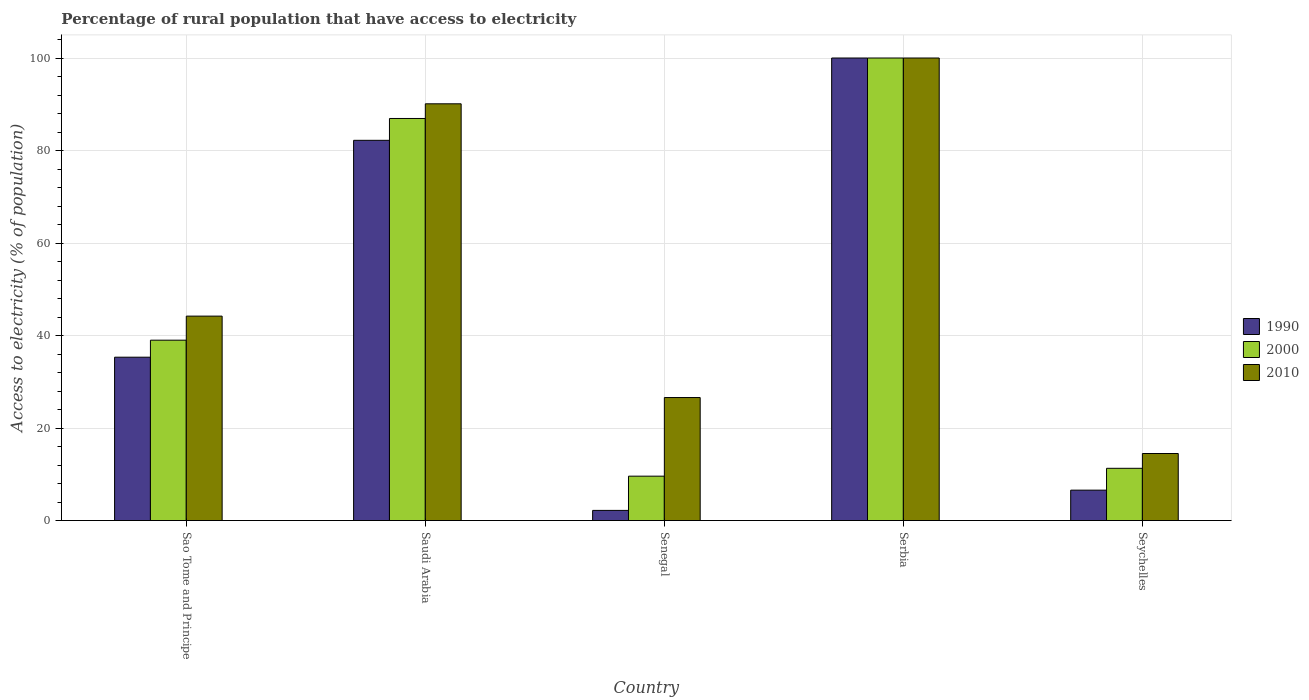How many different coloured bars are there?
Give a very brief answer. 3. How many groups of bars are there?
Make the answer very short. 5. How many bars are there on the 5th tick from the right?
Keep it short and to the point. 3. What is the label of the 1st group of bars from the left?
Your answer should be very brief. Sao Tome and Principe. What is the percentage of rural population that have access to electricity in 2000 in Seychelles?
Make the answer very short. 11.3. In which country was the percentage of rural population that have access to electricity in 2010 maximum?
Offer a very short reply. Serbia. In which country was the percentage of rural population that have access to electricity in 2010 minimum?
Give a very brief answer. Seychelles. What is the total percentage of rural population that have access to electricity in 2010 in the graph?
Provide a short and direct response. 275.4. What is the difference between the percentage of rural population that have access to electricity in 1990 in Sao Tome and Principe and that in Seychelles?
Keep it short and to the point. 28.74. What is the difference between the percentage of rural population that have access to electricity in 2000 in Sao Tome and Principe and the percentage of rural population that have access to electricity in 2010 in Senegal?
Provide a succinct answer. 12.4. What is the average percentage of rural population that have access to electricity in 2000 per country?
Offer a very short reply. 49.37. What is the difference between the percentage of rural population that have access to electricity of/in 2000 and percentage of rural population that have access to electricity of/in 2010 in Seychelles?
Make the answer very short. -3.2. In how many countries, is the percentage of rural population that have access to electricity in 2000 greater than 40 %?
Give a very brief answer. 2. What is the ratio of the percentage of rural population that have access to electricity in 2010 in Sao Tome and Principe to that in Saudi Arabia?
Offer a terse response. 0.49. Is the percentage of rural population that have access to electricity in 2000 in Sao Tome and Principe less than that in Saudi Arabia?
Offer a very short reply. Yes. What is the difference between the highest and the second highest percentage of rural population that have access to electricity in 2000?
Provide a succinct answer. 13.07. What is the difference between the highest and the lowest percentage of rural population that have access to electricity in 2010?
Ensure brevity in your answer.  85.5. Is it the case that in every country, the sum of the percentage of rural population that have access to electricity in 2000 and percentage of rural population that have access to electricity in 1990 is greater than the percentage of rural population that have access to electricity in 2010?
Provide a succinct answer. No. How many bars are there?
Keep it short and to the point. 15. Are all the bars in the graph horizontal?
Ensure brevity in your answer.  No. How many countries are there in the graph?
Your answer should be very brief. 5. What is the difference between two consecutive major ticks on the Y-axis?
Your response must be concise. 20. Where does the legend appear in the graph?
Offer a terse response. Center right. How many legend labels are there?
Provide a succinct answer. 3. What is the title of the graph?
Offer a very short reply. Percentage of rural population that have access to electricity. Does "2005" appear as one of the legend labels in the graph?
Provide a succinct answer. No. What is the label or title of the X-axis?
Offer a very short reply. Country. What is the label or title of the Y-axis?
Your answer should be compact. Access to electricity (% of population). What is the Access to electricity (% of population) in 1990 in Sao Tome and Principe?
Offer a very short reply. 35.32. What is the Access to electricity (% of population) of 2010 in Sao Tome and Principe?
Provide a short and direct response. 44.2. What is the Access to electricity (% of population) in 1990 in Saudi Arabia?
Provide a succinct answer. 82.2. What is the Access to electricity (% of population) in 2000 in Saudi Arabia?
Give a very brief answer. 86.93. What is the Access to electricity (% of population) in 2010 in Saudi Arabia?
Provide a succinct answer. 90.1. What is the Access to electricity (% of population) of 2000 in Senegal?
Offer a terse response. 9.6. What is the Access to electricity (% of population) of 2010 in Senegal?
Your answer should be compact. 26.6. What is the Access to electricity (% of population) of 1990 in Serbia?
Your answer should be very brief. 100. What is the Access to electricity (% of population) of 2010 in Serbia?
Provide a succinct answer. 100. What is the Access to electricity (% of population) in 1990 in Seychelles?
Ensure brevity in your answer.  6.58. What is the Access to electricity (% of population) of 2000 in Seychelles?
Provide a short and direct response. 11.3. Across all countries, what is the maximum Access to electricity (% of population) in 1990?
Your answer should be compact. 100. Across all countries, what is the minimum Access to electricity (% of population) in 1990?
Keep it short and to the point. 2.2. What is the total Access to electricity (% of population) in 1990 in the graph?
Keep it short and to the point. 226.3. What is the total Access to electricity (% of population) in 2000 in the graph?
Your response must be concise. 246.83. What is the total Access to electricity (% of population) of 2010 in the graph?
Your response must be concise. 275.4. What is the difference between the Access to electricity (% of population) in 1990 in Sao Tome and Principe and that in Saudi Arabia?
Give a very brief answer. -46.88. What is the difference between the Access to electricity (% of population) of 2000 in Sao Tome and Principe and that in Saudi Arabia?
Your response must be concise. -47.93. What is the difference between the Access to electricity (% of population) of 2010 in Sao Tome and Principe and that in Saudi Arabia?
Keep it short and to the point. -45.9. What is the difference between the Access to electricity (% of population) of 1990 in Sao Tome and Principe and that in Senegal?
Give a very brief answer. 33.12. What is the difference between the Access to electricity (% of population) of 2000 in Sao Tome and Principe and that in Senegal?
Provide a short and direct response. 29.4. What is the difference between the Access to electricity (% of population) of 1990 in Sao Tome and Principe and that in Serbia?
Ensure brevity in your answer.  -64.68. What is the difference between the Access to electricity (% of population) in 2000 in Sao Tome and Principe and that in Serbia?
Your answer should be very brief. -61. What is the difference between the Access to electricity (% of population) in 2010 in Sao Tome and Principe and that in Serbia?
Make the answer very short. -55.8. What is the difference between the Access to electricity (% of population) in 1990 in Sao Tome and Principe and that in Seychelles?
Give a very brief answer. 28.74. What is the difference between the Access to electricity (% of population) in 2000 in Sao Tome and Principe and that in Seychelles?
Give a very brief answer. 27.7. What is the difference between the Access to electricity (% of population) in 2010 in Sao Tome and Principe and that in Seychelles?
Your response must be concise. 29.7. What is the difference between the Access to electricity (% of population) of 1990 in Saudi Arabia and that in Senegal?
Give a very brief answer. 80. What is the difference between the Access to electricity (% of population) of 2000 in Saudi Arabia and that in Senegal?
Give a very brief answer. 77.33. What is the difference between the Access to electricity (% of population) of 2010 in Saudi Arabia and that in Senegal?
Keep it short and to the point. 63.5. What is the difference between the Access to electricity (% of population) in 1990 in Saudi Arabia and that in Serbia?
Provide a succinct answer. -17.8. What is the difference between the Access to electricity (% of population) of 2000 in Saudi Arabia and that in Serbia?
Give a very brief answer. -13.07. What is the difference between the Access to electricity (% of population) in 2010 in Saudi Arabia and that in Serbia?
Make the answer very short. -9.9. What is the difference between the Access to electricity (% of population) in 1990 in Saudi Arabia and that in Seychelles?
Give a very brief answer. 75.62. What is the difference between the Access to electricity (% of population) of 2000 in Saudi Arabia and that in Seychelles?
Make the answer very short. 75.62. What is the difference between the Access to electricity (% of population) in 2010 in Saudi Arabia and that in Seychelles?
Your answer should be very brief. 75.6. What is the difference between the Access to electricity (% of population) of 1990 in Senegal and that in Serbia?
Your answer should be very brief. -97.8. What is the difference between the Access to electricity (% of population) of 2000 in Senegal and that in Serbia?
Your answer should be very brief. -90.4. What is the difference between the Access to electricity (% of population) of 2010 in Senegal and that in Serbia?
Ensure brevity in your answer.  -73.4. What is the difference between the Access to electricity (% of population) in 1990 in Senegal and that in Seychelles?
Ensure brevity in your answer.  -4.38. What is the difference between the Access to electricity (% of population) of 2000 in Senegal and that in Seychelles?
Your response must be concise. -1.7. What is the difference between the Access to electricity (% of population) in 2010 in Senegal and that in Seychelles?
Offer a very short reply. 12.1. What is the difference between the Access to electricity (% of population) of 1990 in Serbia and that in Seychelles?
Make the answer very short. 93.42. What is the difference between the Access to electricity (% of population) of 2000 in Serbia and that in Seychelles?
Provide a short and direct response. 88.7. What is the difference between the Access to electricity (% of population) in 2010 in Serbia and that in Seychelles?
Provide a succinct answer. 85.5. What is the difference between the Access to electricity (% of population) of 1990 in Sao Tome and Principe and the Access to electricity (% of population) of 2000 in Saudi Arabia?
Offer a very short reply. -51.61. What is the difference between the Access to electricity (% of population) in 1990 in Sao Tome and Principe and the Access to electricity (% of population) in 2010 in Saudi Arabia?
Offer a terse response. -54.78. What is the difference between the Access to electricity (% of population) of 2000 in Sao Tome and Principe and the Access to electricity (% of population) of 2010 in Saudi Arabia?
Offer a terse response. -51.1. What is the difference between the Access to electricity (% of population) in 1990 in Sao Tome and Principe and the Access to electricity (% of population) in 2000 in Senegal?
Offer a terse response. 25.72. What is the difference between the Access to electricity (% of population) of 1990 in Sao Tome and Principe and the Access to electricity (% of population) of 2010 in Senegal?
Give a very brief answer. 8.72. What is the difference between the Access to electricity (% of population) of 1990 in Sao Tome and Principe and the Access to electricity (% of population) of 2000 in Serbia?
Ensure brevity in your answer.  -64.68. What is the difference between the Access to electricity (% of population) of 1990 in Sao Tome and Principe and the Access to electricity (% of population) of 2010 in Serbia?
Offer a terse response. -64.68. What is the difference between the Access to electricity (% of population) in 2000 in Sao Tome and Principe and the Access to electricity (% of population) in 2010 in Serbia?
Make the answer very short. -61. What is the difference between the Access to electricity (% of population) in 1990 in Sao Tome and Principe and the Access to electricity (% of population) in 2000 in Seychelles?
Your answer should be very brief. 24.02. What is the difference between the Access to electricity (% of population) of 1990 in Sao Tome and Principe and the Access to electricity (% of population) of 2010 in Seychelles?
Offer a terse response. 20.82. What is the difference between the Access to electricity (% of population) in 2000 in Sao Tome and Principe and the Access to electricity (% of population) in 2010 in Seychelles?
Give a very brief answer. 24.5. What is the difference between the Access to electricity (% of population) in 1990 in Saudi Arabia and the Access to electricity (% of population) in 2000 in Senegal?
Offer a very short reply. 72.6. What is the difference between the Access to electricity (% of population) in 1990 in Saudi Arabia and the Access to electricity (% of population) in 2010 in Senegal?
Provide a succinct answer. 55.6. What is the difference between the Access to electricity (% of population) in 2000 in Saudi Arabia and the Access to electricity (% of population) in 2010 in Senegal?
Provide a succinct answer. 60.33. What is the difference between the Access to electricity (% of population) of 1990 in Saudi Arabia and the Access to electricity (% of population) of 2000 in Serbia?
Make the answer very short. -17.8. What is the difference between the Access to electricity (% of population) in 1990 in Saudi Arabia and the Access to electricity (% of population) in 2010 in Serbia?
Ensure brevity in your answer.  -17.8. What is the difference between the Access to electricity (% of population) in 2000 in Saudi Arabia and the Access to electricity (% of population) in 2010 in Serbia?
Provide a short and direct response. -13.07. What is the difference between the Access to electricity (% of population) in 1990 in Saudi Arabia and the Access to electricity (% of population) in 2000 in Seychelles?
Keep it short and to the point. 70.9. What is the difference between the Access to electricity (% of population) of 1990 in Saudi Arabia and the Access to electricity (% of population) of 2010 in Seychelles?
Your response must be concise. 67.7. What is the difference between the Access to electricity (% of population) in 2000 in Saudi Arabia and the Access to electricity (% of population) in 2010 in Seychelles?
Your answer should be very brief. 72.43. What is the difference between the Access to electricity (% of population) in 1990 in Senegal and the Access to electricity (% of population) in 2000 in Serbia?
Keep it short and to the point. -97.8. What is the difference between the Access to electricity (% of population) of 1990 in Senegal and the Access to electricity (% of population) of 2010 in Serbia?
Your answer should be very brief. -97.8. What is the difference between the Access to electricity (% of population) of 2000 in Senegal and the Access to electricity (% of population) of 2010 in Serbia?
Your answer should be very brief. -90.4. What is the difference between the Access to electricity (% of population) in 1990 in Senegal and the Access to electricity (% of population) in 2000 in Seychelles?
Keep it short and to the point. -9.1. What is the difference between the Access to electricity (% of population) of 1990 in Senegal and the Access to electricity (% of population) of 2010 in Seychelles?
Offer a very short reply. -12.3. What is the difference between the Access to electricity (% of population) of 2000 in Senegal and the Access to electricity (% of population) of 2010 in Seychelles?
Offer a terse response. -4.9. What is the difference between the Access to electricity (% of population) of 1990 in Serbia and the Access to electricity (% of population) of 2000 in Seychelles?
Your answer should be compact. 88.7. What is the difference between the Access to electricity (% of population) of 1990 in Serbia and the Access to electricity (% of population) of 2010 in Seychelles?
Provide a short and direct response. 85.5. What is the difference between the Access to electricity (% of population) in 2000 in Serbia and the Access to electricity (% of population) in 2010 in Seychelles?
Provide a short and direct response. 85.5. What is the average Access to electricity (% of population) in 1990 per country?
Make the answer very short. 45.26. What is the average Access to electricity (% of population) in 2000 per country?
Your answer should be very brief. 49.37. What is the average Access to electricity (% of population) in 2010 per country?
Offer a very short reply. 55.08. What is the difference between the Access to electricity (% of population) in 1990 and Access to electricity (% of population) in 2000 in Sao Tome and Principe?
Your answer should be compact. -3.68. What is the difference between the Access to electricity (% of population) in 1990 and Access to electricity (% of population) in 2010 in Sao Tome and Principe?
Your answer should be compact. -8.88. What is the difference between the Access to electricity (% of population) in 1990 and Access to electricity (% of population) in 2000 in Saudi Arabia?
Offer a terse response. -4.72. What is the difference between the Access to electricity (% of population) of 1990 and Access to electricity (% of population) of 2010 in Saudi Arabia?
Your answer should be very brief. -7.9. What is the difference between the Access to electricity (% of population) in 2000 and Access to electricity (% of population) in 2010 in Saudi Arabia?
Your response must be concise. -3.17. What is the difference between the Access to electricity (% of population) in 1990 and Access to electricity (% of population) in 2010 in Senegal?
Ensure brevity in your answer.  -24.4. What is the difference between the Access to electricity (% of population) of 2000 and Access to electricity (% of population) of 2010 in Senegal?
Provide a succinct answer. -17. What is the difference between the Access to electricity (% of population) in 1990 and Access to electricity (% of population) in 2000 in Serbia?
Your answer should be very brief. 0. What is the difference between the Access to electricity (% of population) of 1990 and Access to electricity (% of population) of 2010 in Serbia?
Keep it short and to the point. 0. What is the difference between the Access to electricity (% of population) in 2000 and Access to electricity (% of population) in 2010 in Serbia?
Keep it short and to the point. 0. What is the difference between the Access to electricity (% of population) in 1990 and Access to electricity (% of population) in 2000 in Seychelles?
Offer a terse response. -4.72. What is the difference between the Access to electricity (% of population) of 1990 and Access to electricity (% of population) of 2010 in Seychelles?
Provide a succinct answer. -7.92. What is the difference between the Access to electricity (% of population) in 2000 and Access to electricity (% of population) in 2010 in Seychelles?
Your response must be concise. -3.2. What is the ratio of the Access to electricity (% of population) of 1990 in Sao Tome and Principe to that in Saudi Arabia?
Provide a succinct answer. 0.43. What is the ratio of the Access to electricity (% of population) of 2000 in Sao Tome and Principe to that in Saudi Arabia?
Give a very brief answer. 0.45. What is the ratio of the Access to electricity (% of population) of 2010 in Sao Tome and Principe to that in Saudi Arabia?
Your response must be concise. 0.49. What is the ratio of the Access to electricity (% of population) of 1990 in Sao Tome and Principe to that in Senegal?
Ensure brevity in your answer.  16.05. What is the ratio of the Access to electricity (% of population) of 2000 in Sao Tome and Principe to that in Senegal?
Make the answer very short. 4.06. What is the ratio of the Access to electricity (% of population) in 2010 in Sao Tome and Principe to that in Senegal?
Keep it short and to the point. 1.66. What is the ratio of the Access to electricity (% of population) in 1990 in Sao Tome and Principe to that in Serbia?
Provide a short and direct response. 0.35. What is the ratio of the Access to electricity (% of population) in 2000 in Sao Tome and Principe to that in Serbia?
Keep it short and to the point. 0.39. What is the ratio of the Access to electricity (% of population) in 2010 in Sao Tome and Principe to that in Serbia?
Provide a short and direct response. 0.44. What is the ratio of the Access to electricity (% of population) of 1990 in Sao Tome and Principe to that in Seychelles?
Offer a terse response. 5.37. What is the ratio of the Access to electricity (% of population) in 2000 in Sao Tome and Principe to that in Seychelles?
Your response must be concise. 3.45. What is the ratio of the Access to electricity (% of population) in 2010 in Sao Tome and Principe to that in Seychelles?
Ensure brevity in your answer.  3.05. What is the ratio of the Access to electricity (% of population) of 1990 in Saudi Arabia to that in Senegal?
Offer a terse response. 37.37. What is the ratio of the Access to electricity (% of population) of 2000 in Saudi Arabia to that in Senegal?
Make the answer very short. 9.05. What is the ratio of the Access to electricity (% of population) in 2010 in Saudi Arabia to that in Senegal?
Offer a very short reply. 3.39. What is the ratio of the Access to electricity (% of population) of 1990 in Saudi Arabia to that in Serbia?
Ensure brevity in your answer.  0.82. What is the ratio of the Access to electricity (% of population) of 2000 in Saudi Arabia to that in Serbia?
Ensure brevity in your answer.  0.87. What is the ratio of the Access to electricity (% of population) in 2010 in Saudi Arabia to that in Serbia?
Offer a very short reply. 0.9. What is the ratio of the Access to electricity (% of population) in 1990 in Saudi Arabia to that in Seychelles?
Keep it short and to the point. 12.49. What is the ratio of the Access to electricity (% of population) in 2000 in Saudi Arabia to that in Seychelles?
Ensure brevity in your answer.  7.69. What is the ratio of the Access to electricity (% of population) of 2010 in Saudi Arabia to that in Seychelles?
Your answer should be compact. 6.21. What is the ratio of the Access to electricity (% of population) in 1990 in Senegal to that in Serbia?
Your answer should be very brief. 0.02. What is the ratio of the Access to electricity (% of population) of 2000 in Senegal to that in Serbia?
Provide a succinct answer. 0.1. What is the ratio of the Access to electricity (% of population) in 2010 in Senegal to that in Serbia?
Provide a short and direct response. 0.27. What is the ratio of the Access to electricity (% of population) of 1990 in Senegal to that in Seychelles?
Your answer should be very brief. 0.33. What is the ratio of the Access to electricity (% of population) of 2000 in Senegal to that in Seychelles?
Keep it short and to the point. 0.85. What is the ratio of the Access to electricity (% of population) in 2010 in Senegal to that in Seychelles?
Keep it short and to the point. 1.83. What is the ratio of the Access to electricity (% of population) of 1990 in Serbia to that in Seychelles?
Offer a very short reply. 15.2. What is the ratio of the Access to electricity (% of population) in 2000 in Serbia to that in Seychelles?
Offer a very short reply. 8.85. What is the ratio of the Access to electricity (% of population) of 2010 in Serbia to that in Seychelles?
Your answer should be compact. 6.9. What is the difference between the highest and the second highest Access to electricity (% of population) in 1990?
Your answer should be very brief. 17.8. What is the difference between the highest and the second highest Access to electricity (% of population) of 2000?
Offer a very short reply. 13.07. What is the difference between the highest and the second highest Access to electricity (% of population) of 2010?
Ensure brevity in your answer.  9.9. What is the difference between the highest and the lowest Access to electricity (% of population) in 1990?
Your answer should be very brief. 97.8. What is the difference between the highest and the lowest Access to electricity (% of population) of 2000?
Provide a short and direct response. 90.4. What is the difference between the highest and the lowest Access to electricity (% of population) of 2010?
Offer a terse response. 85.5. 